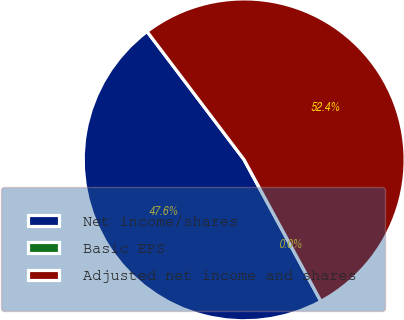Convert chart to OTSL. <chart><loc_0><loc_0><loc_500><loc_500><pie_chart><fcel>Net income/shares<fcel>Basic EPS<fcel>Adjusted net income and shares<nl><fcel>47.6%<fcel>0.0%<fcel>52.4%<nl></chart> 